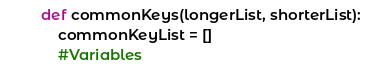Convert code to text. <code><loc_0><loc_0><loc_500><loc_500><_Python_>def commonKeys(longerList, shorterList):
    commonKeyList = []
    #Variables</code> 